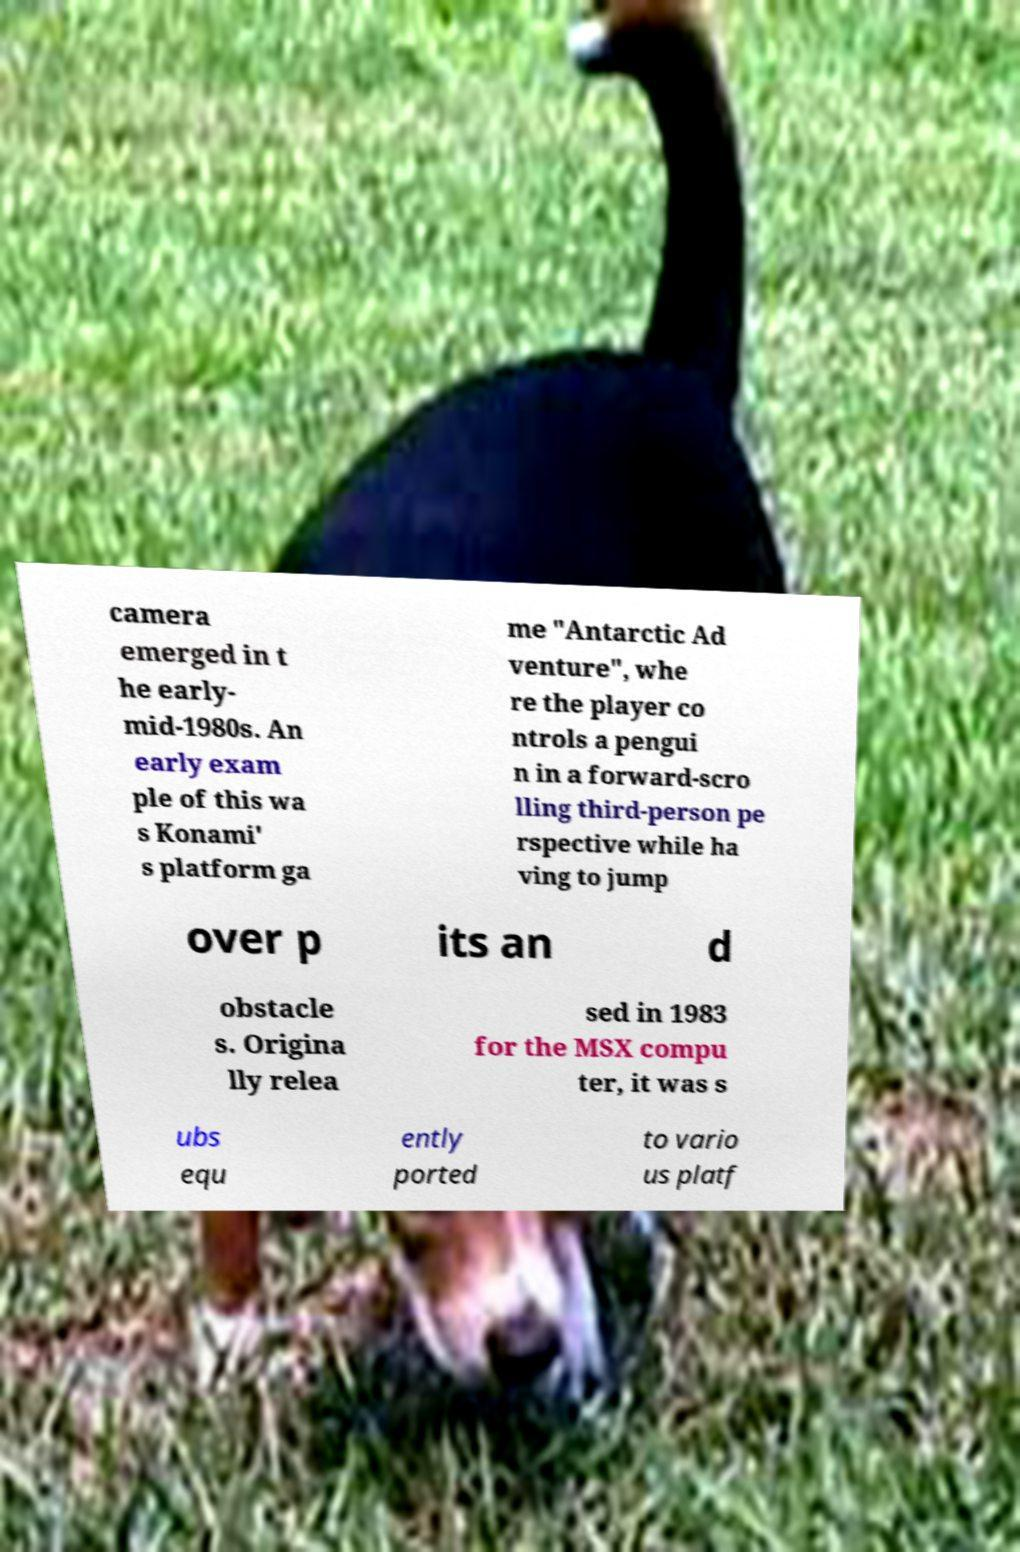Can you accurately transcribe the text from the provided image for me? camera emerged in t he early- mid-1980s. An early exam ple of this wa s Konami' s platform ga me "Antarctic Ad venture", whe re the player co ntrols a pengui n in a forward-scro lling third-person pe rspective while ha ving to jump over p its an d obstacle s. Origina lly relea sed in 1983 for the MSX compu ter, it was s ubs equ ently ported to vario us platf 